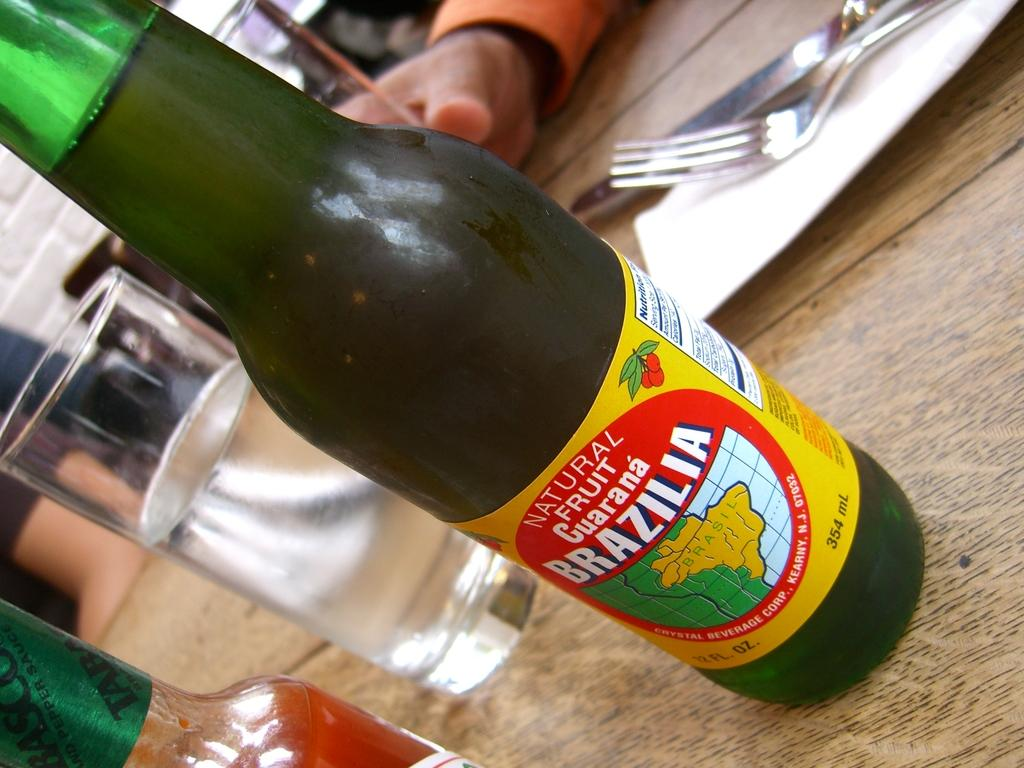<image>
Relay a brief, clear account of the picture shown. Bottle of Natural Fruit Guarana Brazilia on a table next to some tobasco sauce. 